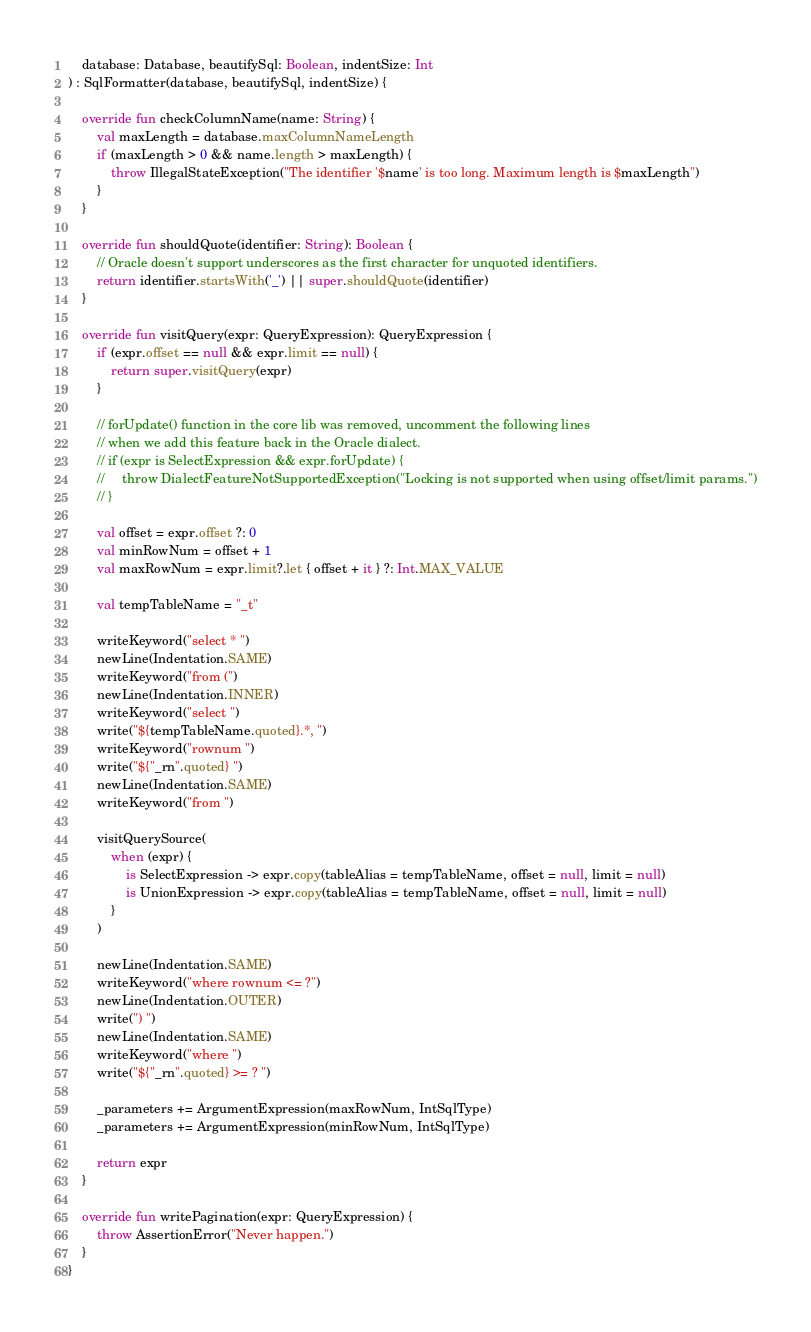Convert code to text. <code><loc_0><loc_0><loc_500><loc_500><_Kotlin_>    database: Database, beautifySql: Boolean, indentSize: Int
) : SqlFormatter(database, beautifySql, indentSize) {

    override fun checkColumnName(name: String) {
        val maxLength = database.maxColumnNameLength
        if (maxLength > 0 && name.length > maxLength) {
            throw IllegalStateException("The identifier '$name' is too long. Maximum length is $maxLength")
        }
    }

    override fun shouldQuote(identifier: String): Boolean {
        // Oracle doesn't support underscores as the first character for unquoted identifiers.
        return identifier.startsWith('_') || super.shouldQuote(identifier)
    }

    override fun visitQuery(expr: QueryExpression): QueryExpression {
        if (expr.offset == null && expr.limit == null) {
            return super.visitQuery(expr)
        }

        // forUpdate() function in the core lib was removed, uncomment the following lines
        // when we add this feature back in the Oracle dialect.
        // if (expr is SelectExpression && expr.forUpdate) {
        //     throw DialectFeatureNotSupportedException("Locking is not supported when using offset/limit params.")
        // }

        val offset = expr.offset ?: 0
        val minRowNum = offset + 1
        val maxRowNum = expr.limit?.let { offset + it } ?: Int.MAX_VALUE

        val tempTableName = "_t"

        writeKeyword("select * ")
        newLine(Indentation.SAME)
        writeKeyword("from (")
        newLine(Indentation.INNER)
        writeKeyword("select ")
        write("${tempTableName.quoted}.*, ")
        writeKeyword("rownum ")
        write("${"_rn".quoted} ")
        newLine(Indentation.SAME)
        writeKeyword("from ")

        visitQuerySource(
            when (expr) {
                is SelectExpression -> expr.copy(tableAlias = tempTableName, offset = null, limit = null)
                is UnionExpression -> expr.copy(tableAlias = tempTableName, offset = null, limit = null)
            }
        )

        newLine(Indentation.SAME)
        writeKeyword("where rownum <= ?")
        newLine(Indentation.OUTER)
        write(") ")
        newLine(Indentation.SAME)
        writeKeyword("where ")
        write("${"_rn".quoted} >= ? ")

        _parameters += ArgumentExpression(maxRowNum, IntSqlType)
        _parameters += ArgumentExpression(minRowNum, IntSqlType)

        return expr
    }

    override fun writePagination(expr: QueryExpression) {
        throw AssertionError("Never happen.")
    }
}
</code> 